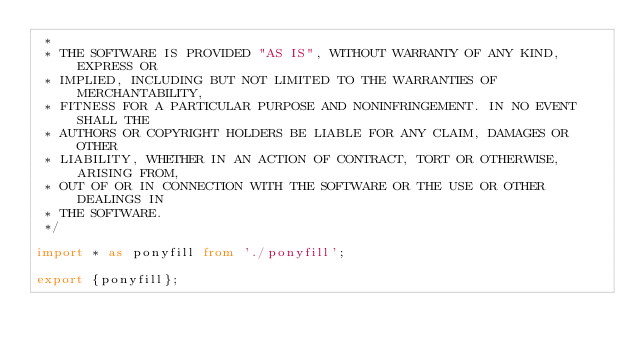<code> <loc_0><loc_0><loc_500><loc_500><_TypeScript_> *
 * THE SOFTWARE IS PROVIDED "AS IS", WITHOUT WARRANTY OF ANY KIND, EXPRESS OR
 * IMPLIED, INCLUDING BUT NOT LIMITED TO THE WARRANTIES OF MERCHANTABILITY,
 * FITNESS FOR A PARTICULAR PURPOSE AND NONINFRINGEMENT. IN NO EVENT SHALL THE
 * AUTHORS OR COPYRIGHT HOLDERS BE LIABLE FOR ANY CLAIM, DAMAGES OR OTHER
 * LIABILITY, WHETHER IN AN ACTION OF CONTRACT, TORT OR OTHERWISE, ARISING FROM,
 * OUT OF OR IN CONNECTION WITH THE SOFTWARE OR THE USE OR OTHER DEALINGS IN
 * THE SOFTWARE.
 */

import * as ponyfill from './ponyfill';

export {ponyfill};
</code> 